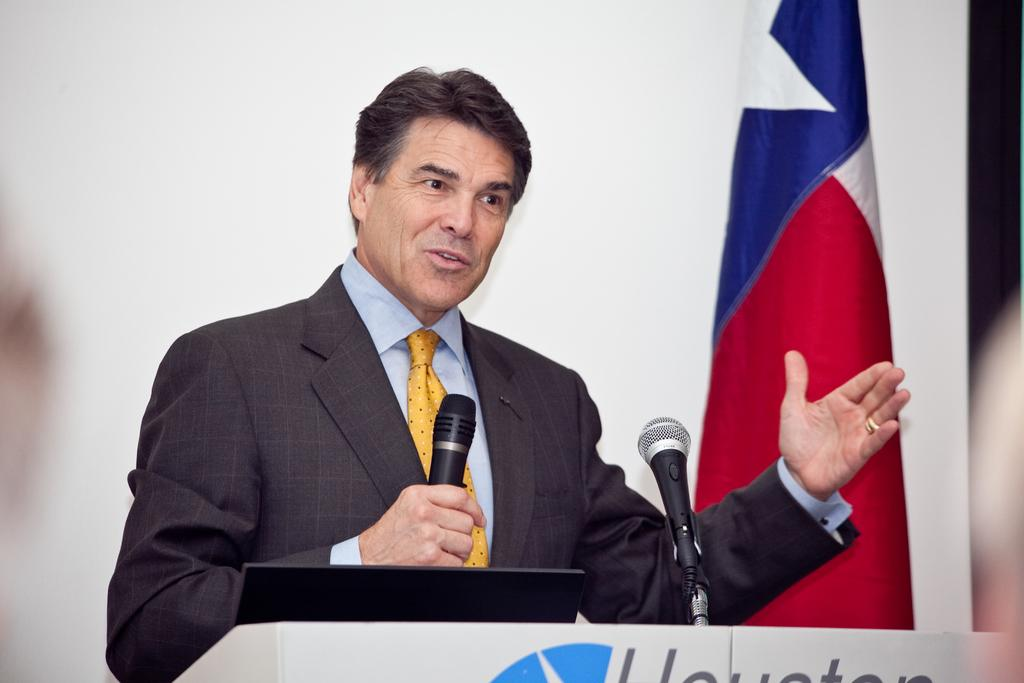What is the person in the image doing? The person is standing at a desk and holding a mic. What can be seen behind the person in the image? There is a wall and a flag in the background of the image. What type of battle is taking place in the image? There is no battle present in the image; it features a person standing at a desk holding a mic. What is the current state of the nation depicted in the image? There is no nation depicted in the image, as it only shows a person standing at a desk holding a mic and a background with a wall and a flag. 